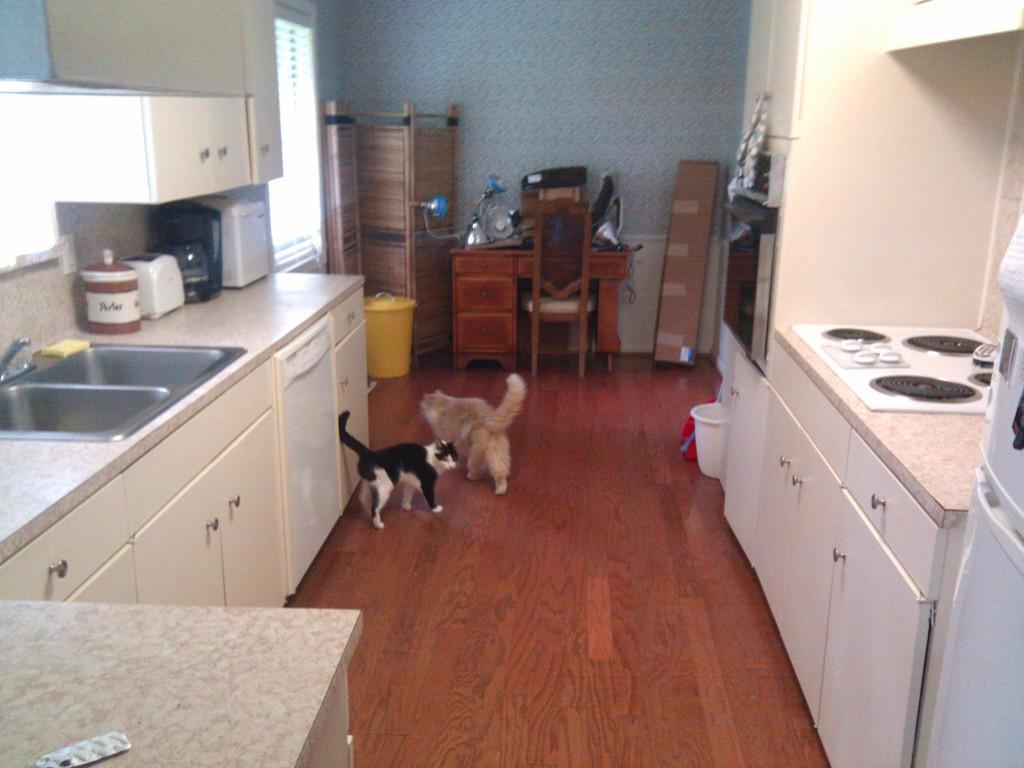In one or two sentences, can you explain what this image depicts? The image consist of a kitchen and two cats. To the left there is a wash basin, below that there are cupboards. In the background, there are tables, lights and a wall. To the right, there is a stove. 